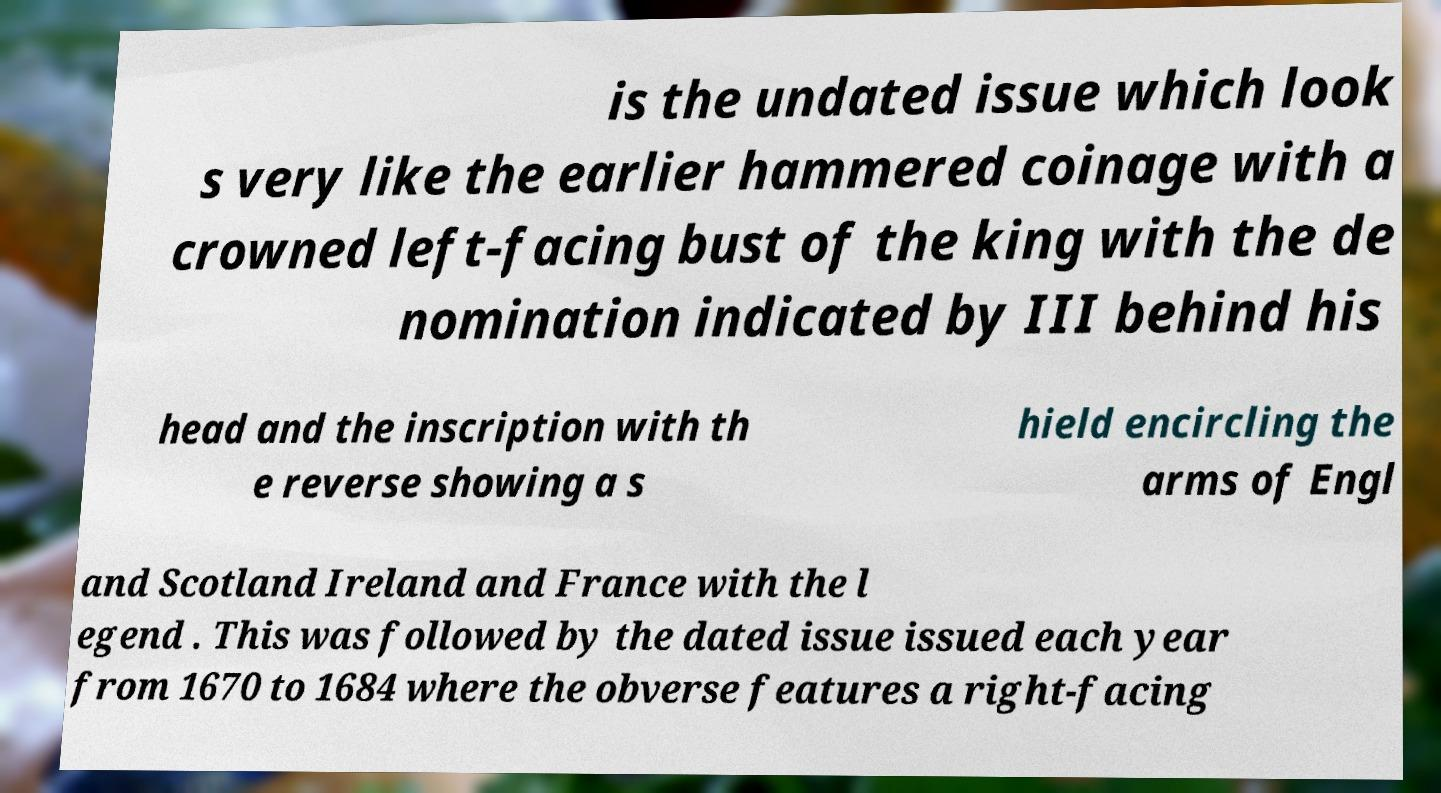For documentation purposes, I need the text within this image transcribed. Could you provide that? is the undated issue which look s very like the earlier hammered coinage with a crowned left-facing bust of the king with the de nomination indicated by III behind his head and the inscription with th e reverse showing a s hield encircling the arms of Engl and Scotland Ireland and France with the l egend . This was followed by the dated issue issued each year from 1670 to 1684 where the obverse features a right-facing 